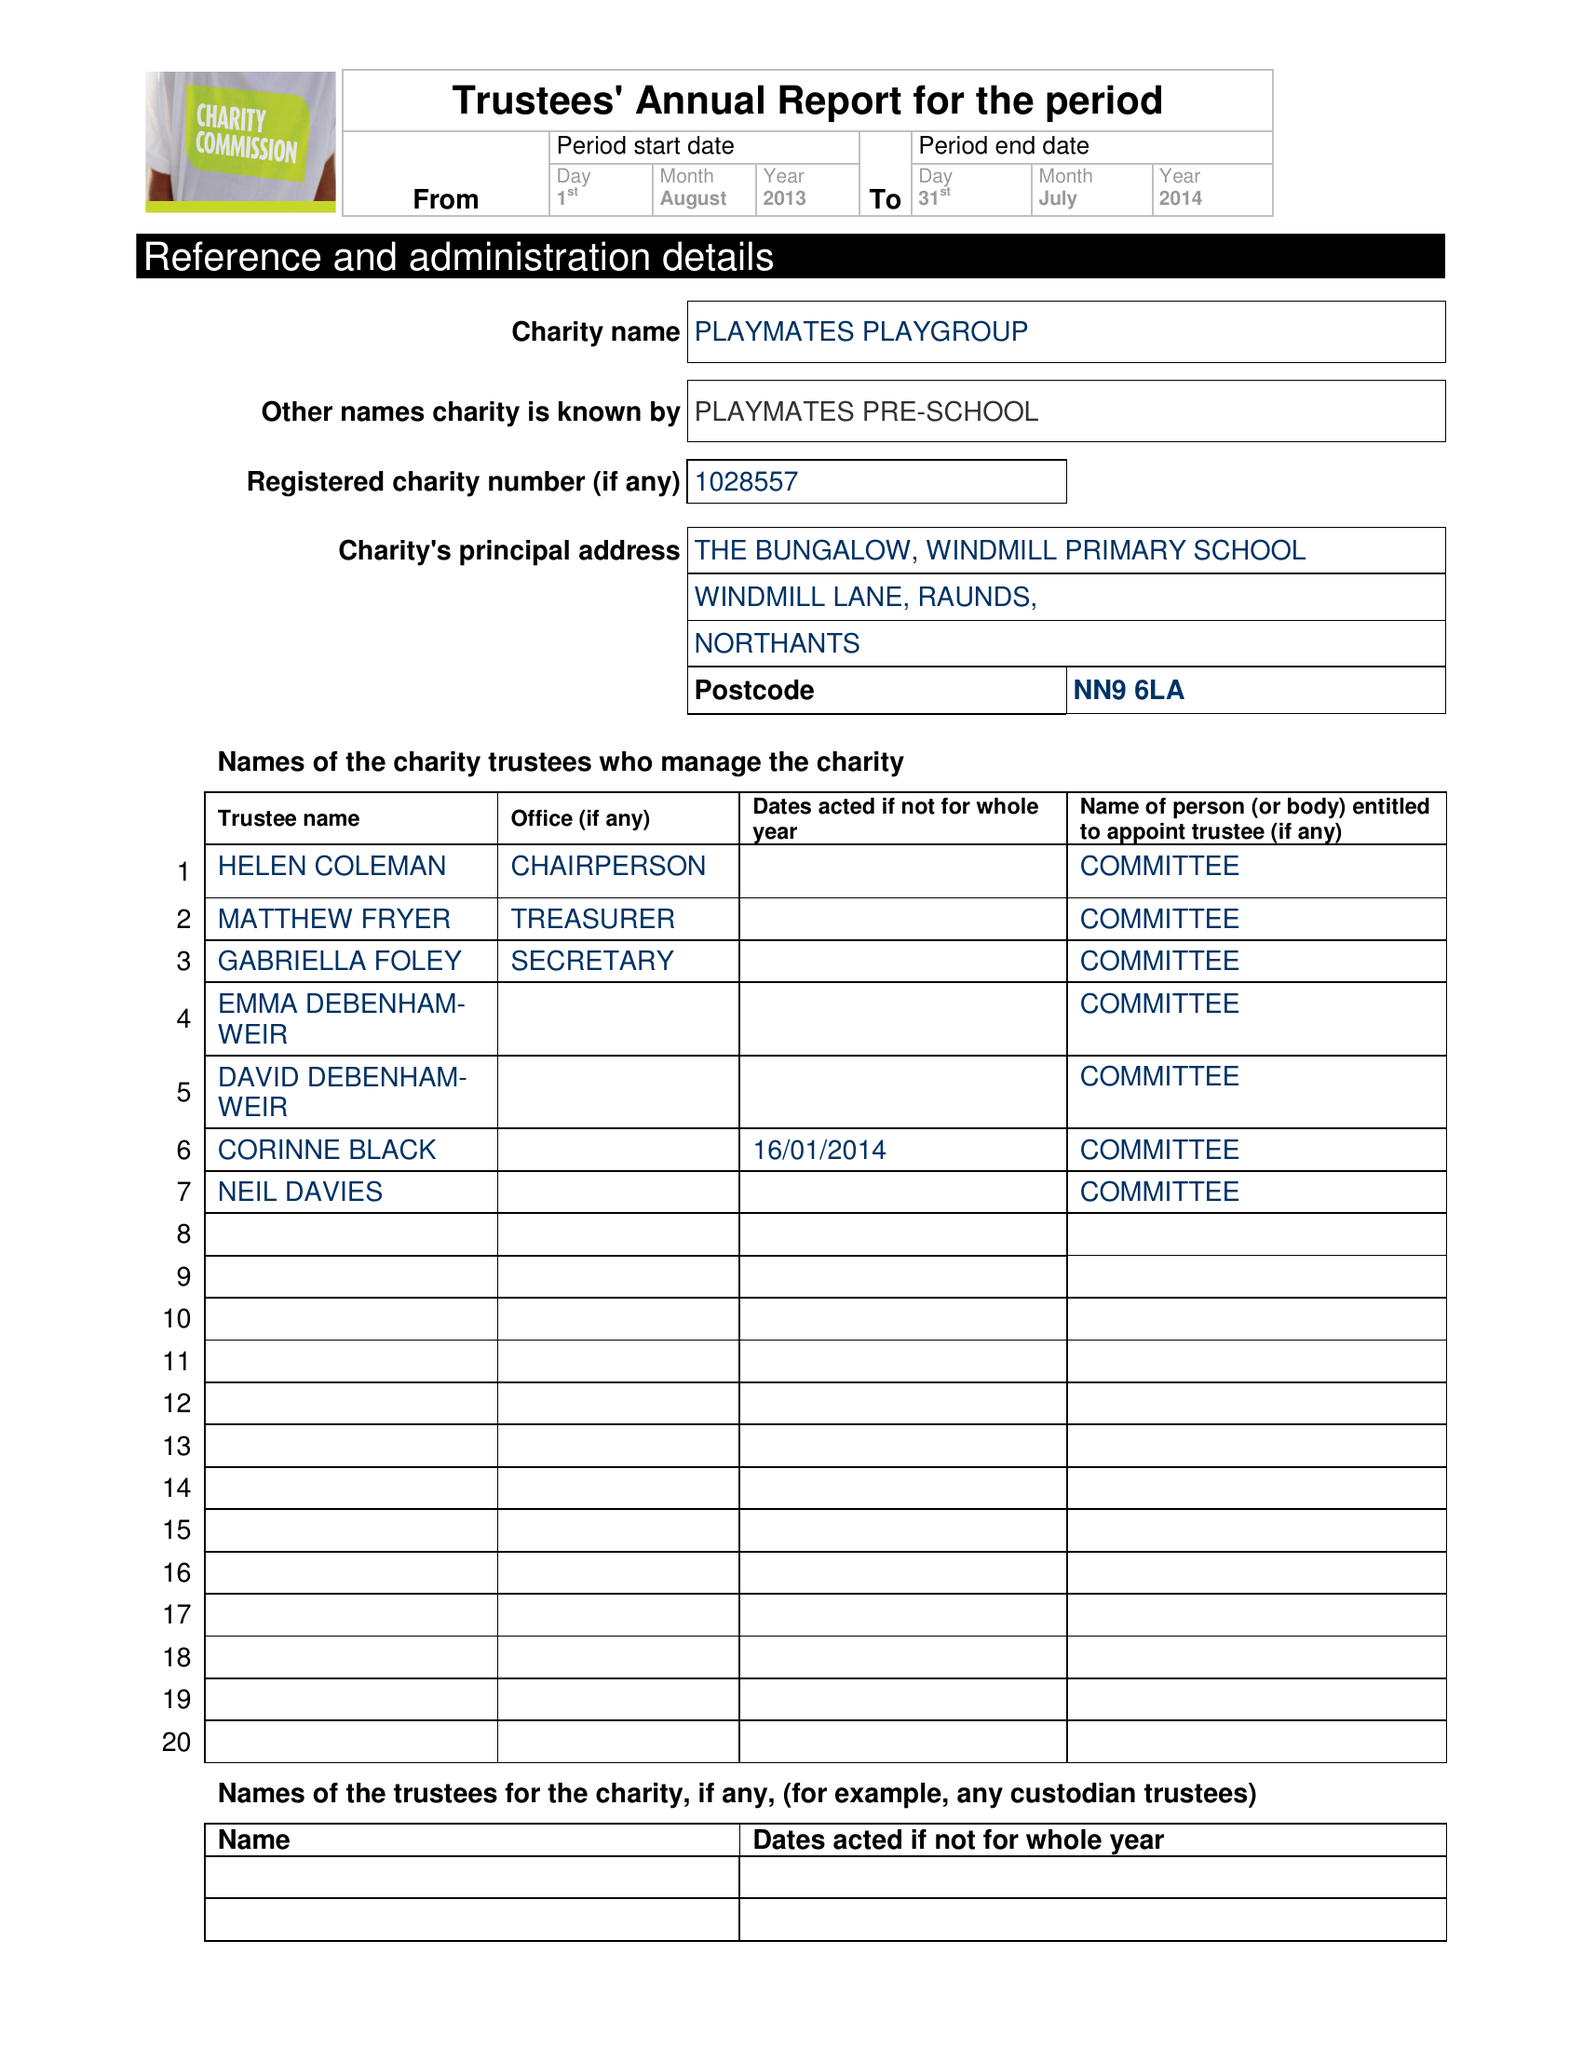What is the value for the report_date?
Answer the question using a single word or phrase. 2014-07-31 